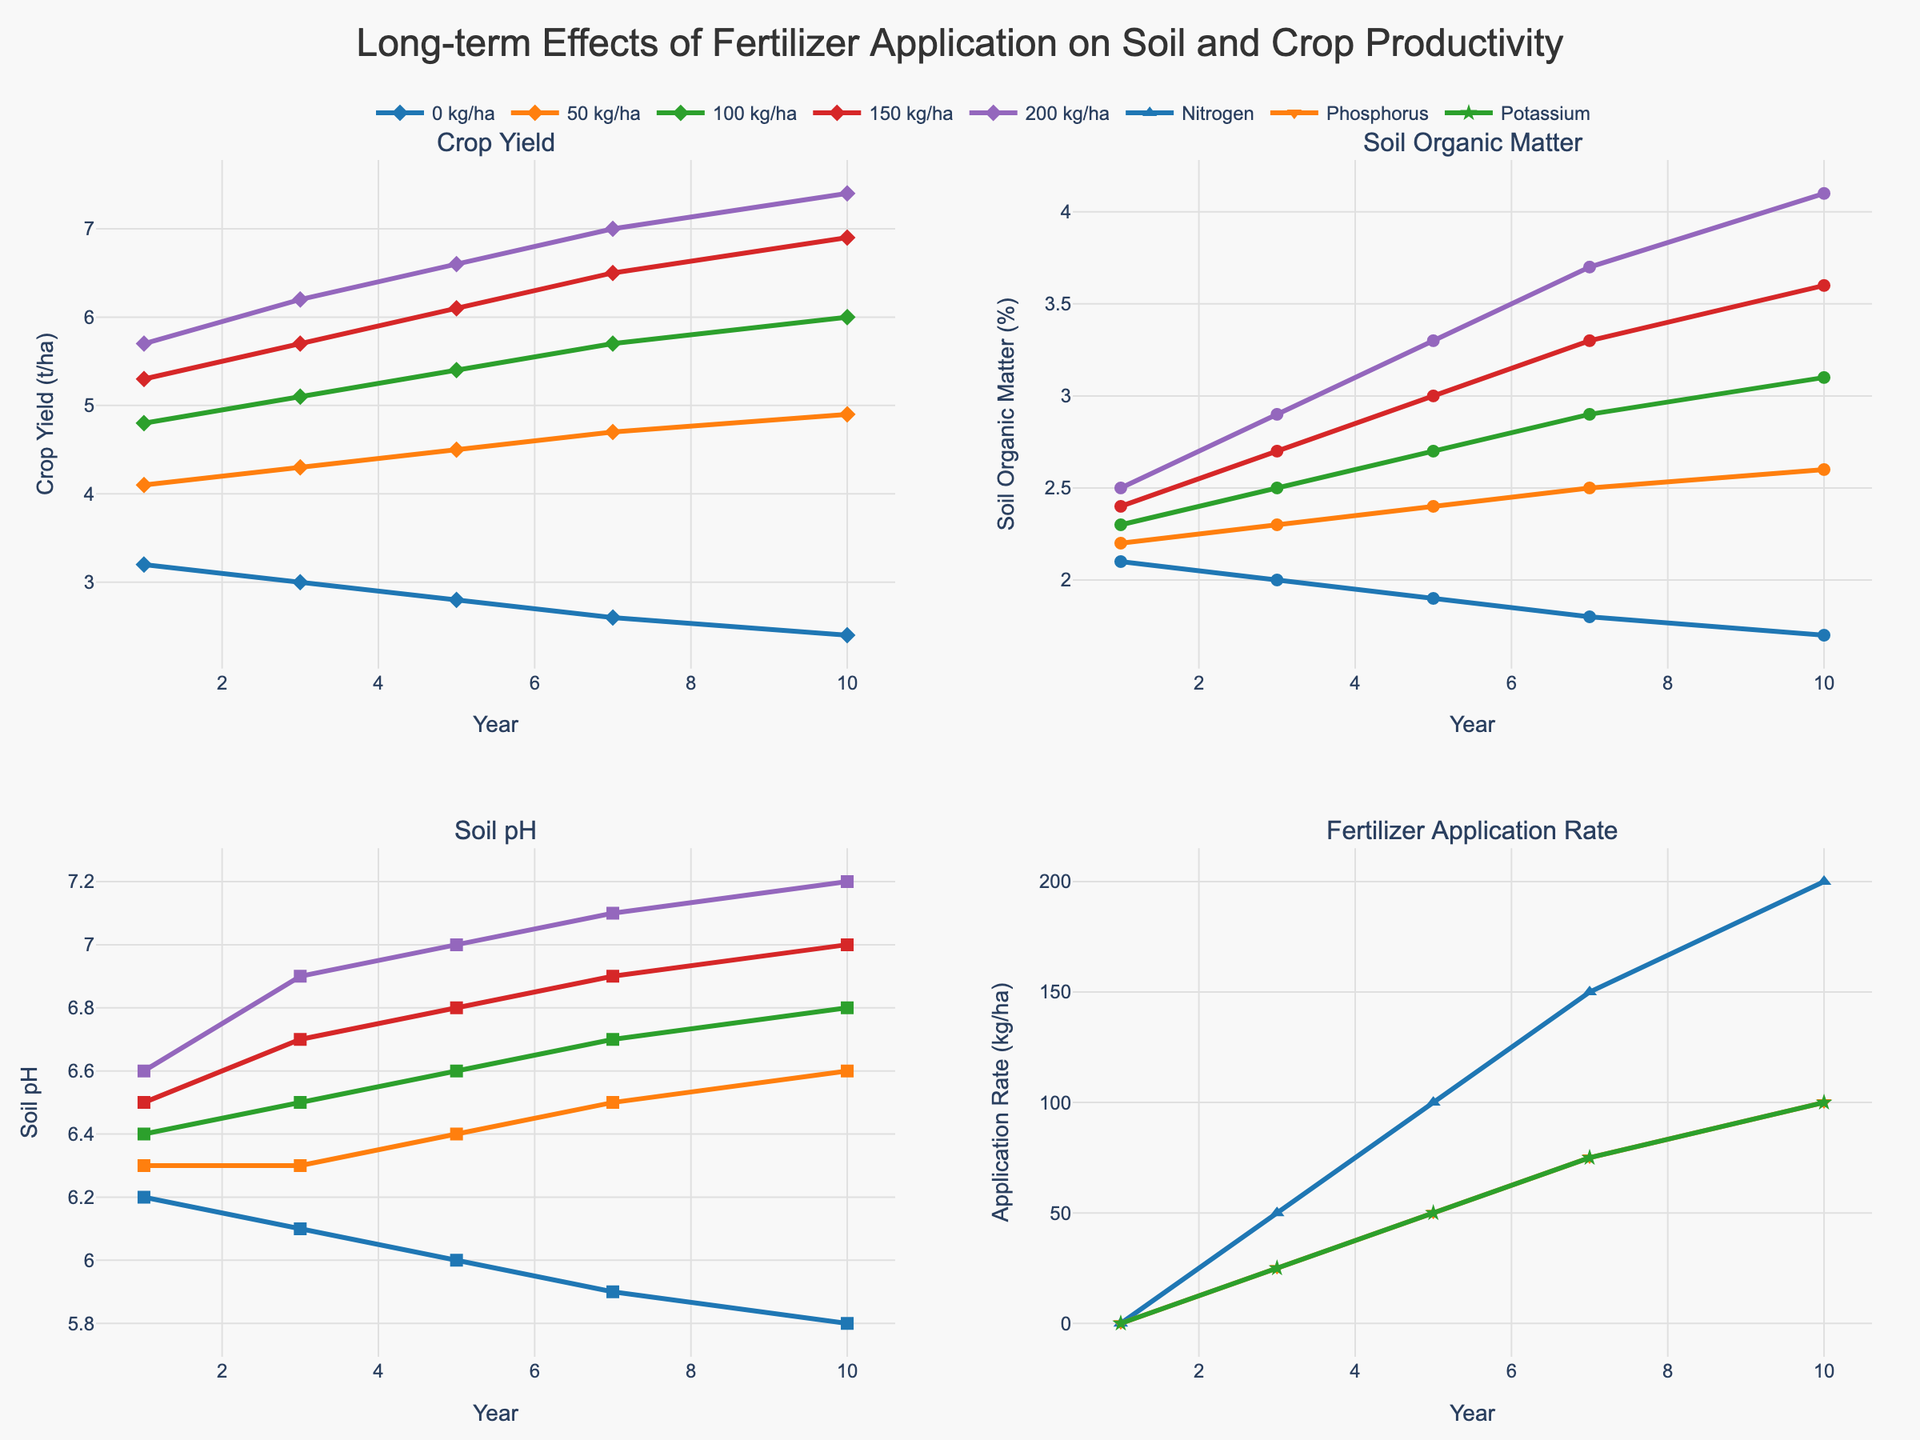What's the trend in crop yield over the 10 years for the highest fertilizer application rate (200 kg/ha)? Looking at the first subplot (Crop Yield), identify the line representing the highest fertilizer rate (200 kg/ha). Observe the data points at year 1, 3, 5, 7, and 10. Note the crop yield values at these years and describe the overall trend.
Answer: Increasing trend Which fertilizer application rate shows the highest increase in soil organic matter percentage from year 1 to year 10? Refer to the second subplot (Soil Organic Matter) for different rates. Calculate the difference between the values at year 10 and year 1 for each rate. The rate with the highest difference is the one we're looking for.
Answer: 200 kg/ha How does the soil pH change for the zero fertilizer application rate over 10 years? Look at the third subplot (Soil pH), and focus on the data series that represents the 0 kg/ha rate. Observe the changes in soil pH values at year 1, 3, 5, 7, and 10.
Answer: Decreasing trend Compare the crop yield at year 10 for the 100 kg/ha and 150 kg/ha fertilizer rates. Which one is higher and by how much? Refer to the first subplot (Crop Yield). Find the crop yield values for 100 kg/ha and 150 kg/ha at year 10 and subtract the former from the latter.
Answer: 6.9 - 6.0 = 0.9 t/ha higher for 150 kg/ha At which year and with which fertilizer application rate does the soil pH reach its highest value? Examine the third subplot (Soil pH) for all fertilizer application rates across different years. Identify the highest soil pH value and note the corresponding year and fertilizer rate.
Answer: Year 10, 200 kg/ha What's the average soil organic matter percentage across all fertilizer rates at year 5? Check the second subplot (Soil Organic Matter) for year 5 and all rates. Calculate the average of the soil organic matter percentages at year 5.
Answer: (1.9 + 2.4 + 2.7 + 3.0 + 3.3) / 5 = 2.66% Which fertilizer rate has the least difference in crop yield between year 1 and year 10? Look at the first subplot (Crop Yield) and note the crop yield values for each rate at year 1 and year 10. Calculate the differences for each rate and identify the smallest one.
Answer: 0 kg/ha What is the overall pattern in the application rates over the years for Nitrogen, Phosphorus, and Potassium? Refer to the fourth subplot (Fertilizer Application Rate). Observe the lines representing these nutrients over the years.
Answer: Constant What is the combined soil organic matter percentage for all rates at year 7? Look at the second subplot (Soil Organic Matter) for year 7. Add the soil organic matter values for all rates.
Answer: 1.8 + 2.5 + 2.9 + 3.3 + 3.7 = 14.2% How much does crop yield increase from year 1 to year 10 for 50 kg/ha application rate? Check the first subplot (Crop Yield). Subtract the crop yield at year 1 from the yield at year 10 for 50 kg/ha.
Answer: 4.9 - 4.1 = 0.8 t/ha 